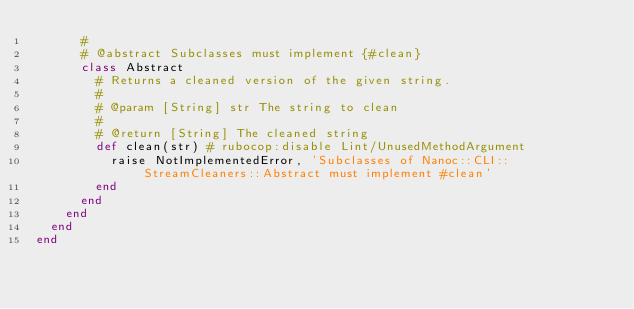Convert code to text. <code><loc_0><loc_0><loc_500><loc_500><_Ruby_>      #
      # @abstract Subclasses must implement {#clean}
      class Abstract
        # Returns a cleaned version of the given string.
        #
        # @param [String] str The string to clean
        #
        # @return [String] The cleaned string
        def clean(str) # rubocop:disable Lint/UnusedMethodArgument
          raise NotImplementedError, 'Subclasses of Nanoc::CLI::StreamCleaners::Abstract must implement #clean'
        end
      end
    end
  end
end
</code> 